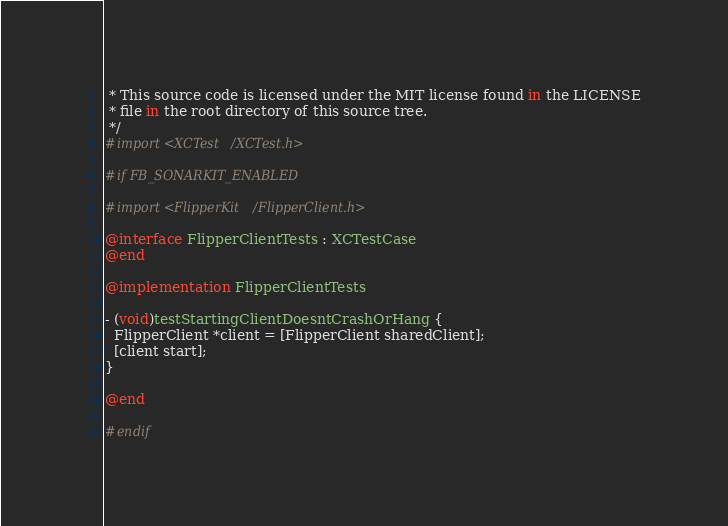<code> <loc_0><loc_0><loc_500><loc_500><_ObjectiveC_> * This source code is licensed under the MIT license found in the LICENSE
 * file in the root directory of this source tree.
 */
#import <XCTest/XCTest.h>

#if FB_SONARKIT_ENABLED

#import <FlipperKit/FlipperClient.h>

@interface FlipperClientTests : XCTestCase
@end

@implementation FlipperClientTests

- (void)testStartingClientDoesntCrashOrHang {
  FlipperClient *client = [FlipperClient sharedClient];
  [client start];
}

@end

#endif
</code> 